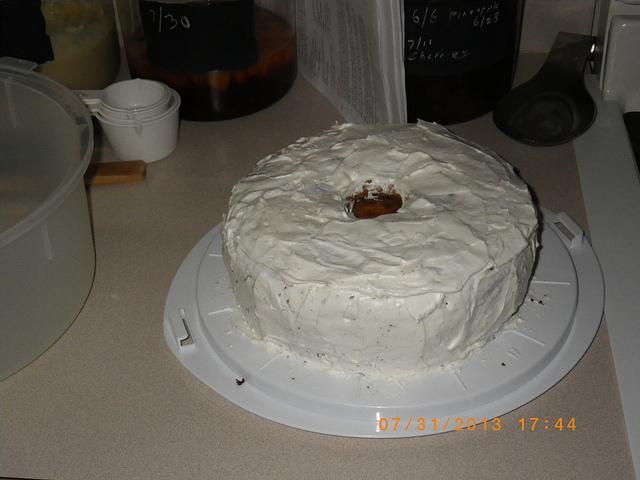How many people do you see?
Give a very brief answer. 0. 